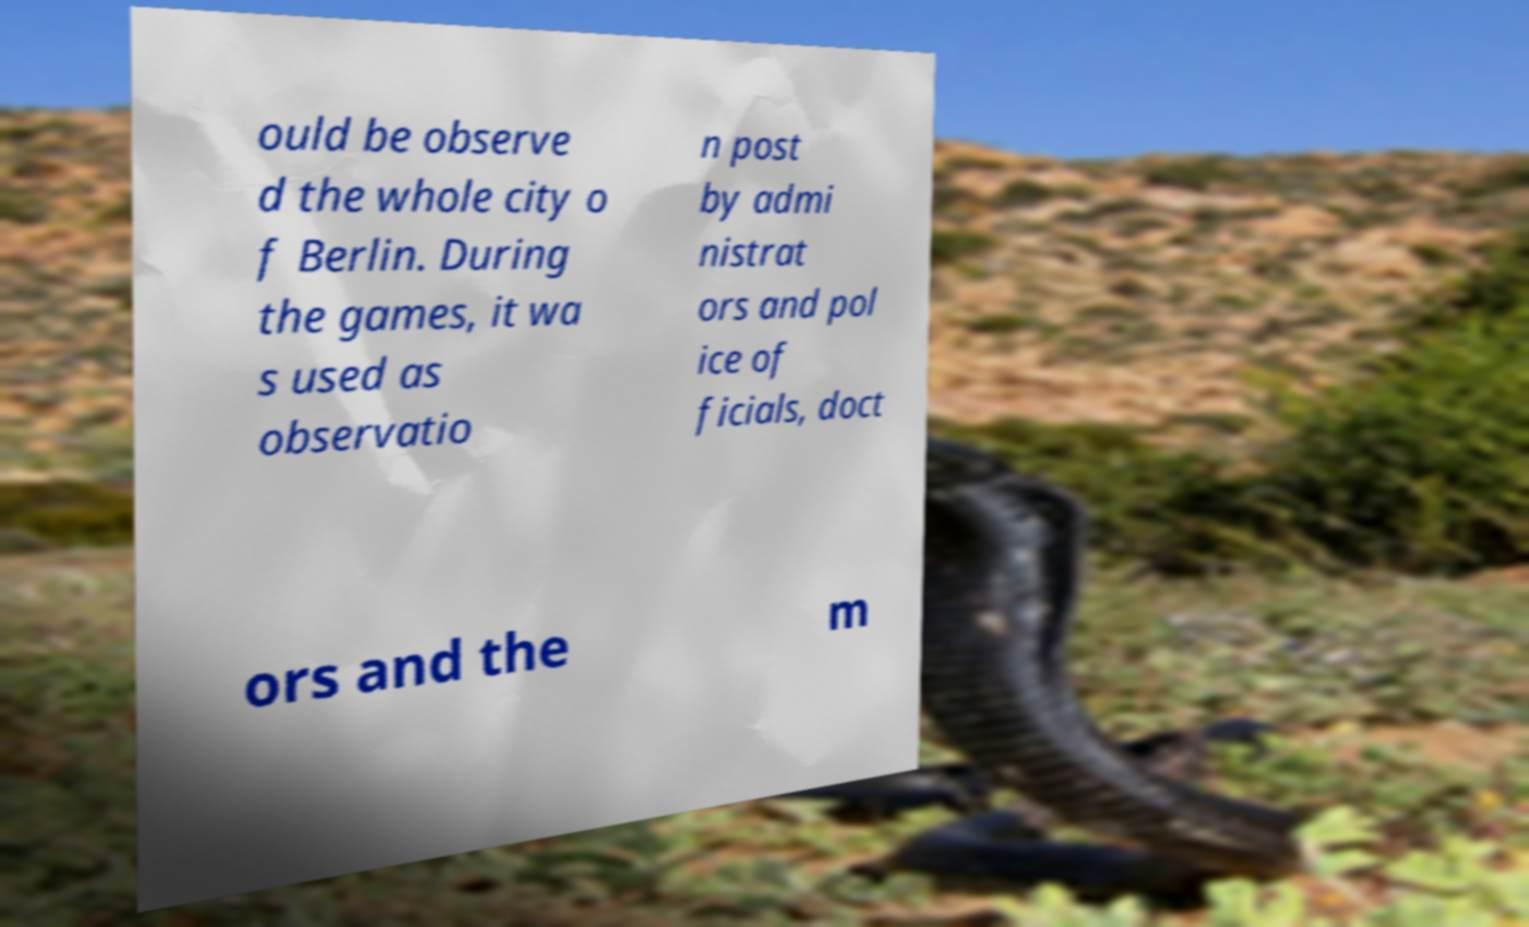Can you accurately transcribe the text from the provided image for me? ould be observe d the whole city o f Berlin. During the games, it wa s used as observatio n post by admi nistrat ors and pol ice of ficials, doct ors and the m 